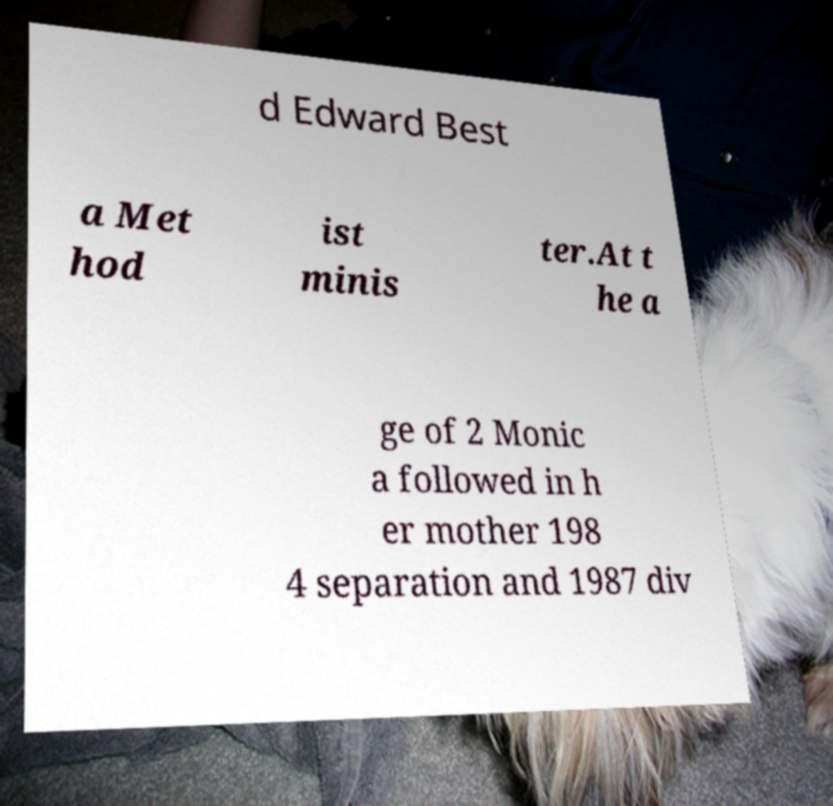Can you accurately transcribe the text from the provided image for me? d Edward Best a Met hod ist minis ter.At t he a ge of 2 Monic a followed in h er mother 198 4 separation and 1987 div 